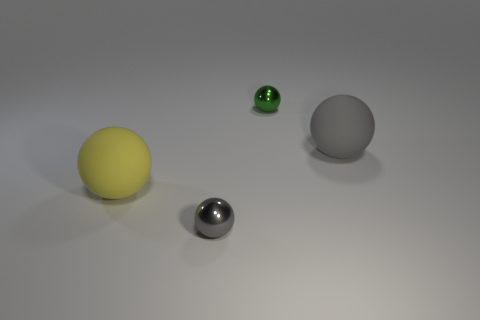Add 2 tiny green balls. How many objects exist? 6 Subtract all yellow balls. How many balls are left? 3 Subtract 1 spheres. How many spheres are left? 3 Subtract all gray spheres. How many spheres are left? 2 Subtract all blue blocks. How many blue spheres are left? 0 Subtract all big blue objects. Subtract all tiny things. How many objects are left? 2 Add 3 big things. How many big things are left? 5 Add 4 big yellow rubber balls. How many big yellow rubber balls exist? 5 Subtract 0 blue cylinders. How many objects are left? 4 Subtract all purple balls. Subtract all brown cylinders. How many balls are left? 4 